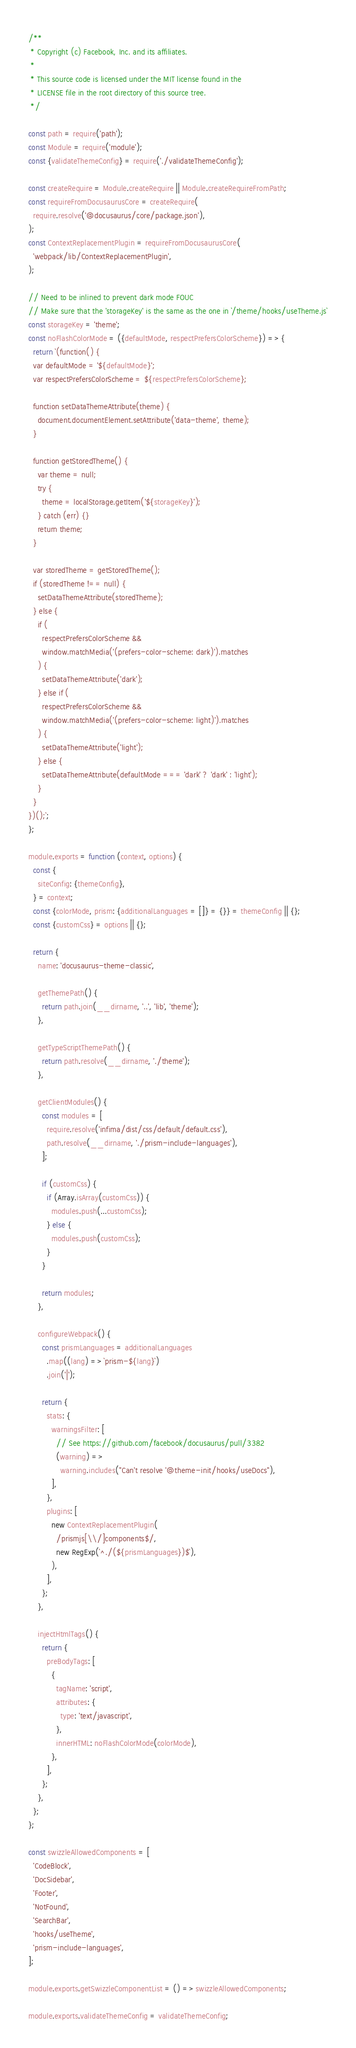<code> <loc_0><loc_0><loc_500><loc_500><_JavaScript_>/**
 * Copyright (c) Facebook, Inc. and its affiliates.
 *
 * This source code is licensed under the MIT license found in the
 * LICENSE file in the root directory of this source tree.
 */

const path = require('path');
const Module = require('module');
const {validateThemeConfig} = require('./validateThemeConfig');

const createRequire = Module.createRequire || Module.createRequireFromPath;
const requireFromDocusaurusCore = createRequire(
  require.resolve('@docusaurus/core/package.json'),
);
const ContextReplacementPlugin = requireFromDocusaurusCore(
  'webpack/lib/ContextReplacementPlugin',
);

// Need to be inlined to prevent dark mode FOUC
// Make sure that the 'storageKey' is the same as the one in `/theme/hooks/useTheme.js`
const storageKey = 'theme';
const noFlashColorMode = ({defaultMode, respectPrefersColorScheme}) => {
  return `(function() {
  var defaultMode = '${defaultMode}';
  var respectPrefersColorScheme = ${respectPrefersColorScheme};

  function setDataThemeAttribute(theme) {
    document.documentElement.setAttribute('data-theme', theme);
  }

  function getStoredTheme() {
    var theme = null;
    try {
      theme = localStorage.getItem('${storageKey}');
    } catch (err) {}
    return theme;
  }

  var storedTheme = getStoredTheme();
  if (storedTheme !== null) {
    setDataThemeAttribute(storedTheme);
  } else {
    if (
      respectPrefersColorScheme &&
      window.matchMedia('(prefers-color-scheme: dark)').matches
    ) {
      setDataThemeAttribute('dark');
    } else if (
      respectPrefersColorScheme &&
      window.matchMedia('(prefers-color-scheme: light)').matches
    ) {
      setDataThemeAttribute('light');
    } else {
      setDataThemeAttribute(defaultMode === 'dark' ? 'dark' : 'light');
    }
  }
})();`;
};

module.exports = function (context, options) {
  const {
    siteConfig: {themeConfig},
  } = context;
  const {colorMode, prism: {additionalLanguages = []} = {}} = themeConfig || {};
  const {customCss} = options || {};

  return {
    name: 'docusaurus-theme-classic',

    getThemePath() {
      return path.join(__dirname, '..', 'lib', 'theme');
    },

    getTypeScriptThemePath() {
      return path.resolve(__dirname, './theme');
    },

    getClientModules() {
      const modules = [
        require.resolve('infima/dist/css/default/default.css'),
        path.resolve(__dirname, './prism-include-languages'),
      ];

      if (customCss) {
        if (Array.isArray(customCss)) {
          modules.push(...customCss);
        } else {
          modules.push(customCss);
        }
      }

      return modules;
    },

    configureWebpack() {
      const prismLanguages = additionalLanguages
        .map((lang) => `prism-${lang}`)
        .join('|');

      return {
        stats: {
          warningsFilter: [
            // See https://github.com/facebook/docusaurus/pull/3382
            (warning) =>
              warning.includes("Can't resolve '@theme-init/hooks/useDocs"),
          ],
        },
        plugins: [
          new ContextReplacementPlugin(
            /prismjs[\\/]components$/,
            new RegExp(`^./(${prismLanguages})$`),
          ),
        ],
      };
    },

    injectHtmlTags() {
      return {
        preBodyTags: [
          {
            tagName: 'script',
            attributes: {
              type: 'text/javascript',
            },
            innerHTML: noFlashColorMode(colorMode),
          },
        ],
      };
    },
  };
};

const swizzleAllowedComponents = [
  'CodeBlock',
  'DocSidebar',
  'Footer',
  'NotFound',
  'SearchBar',
  'hooks/useTheme',
  'prism-include-languages',
];

module.exports.getSwizzleComponentList = () => swizzleAllowedComponents;

module.exports.validateThemeConfig = validateThemeConfig;
</code> 